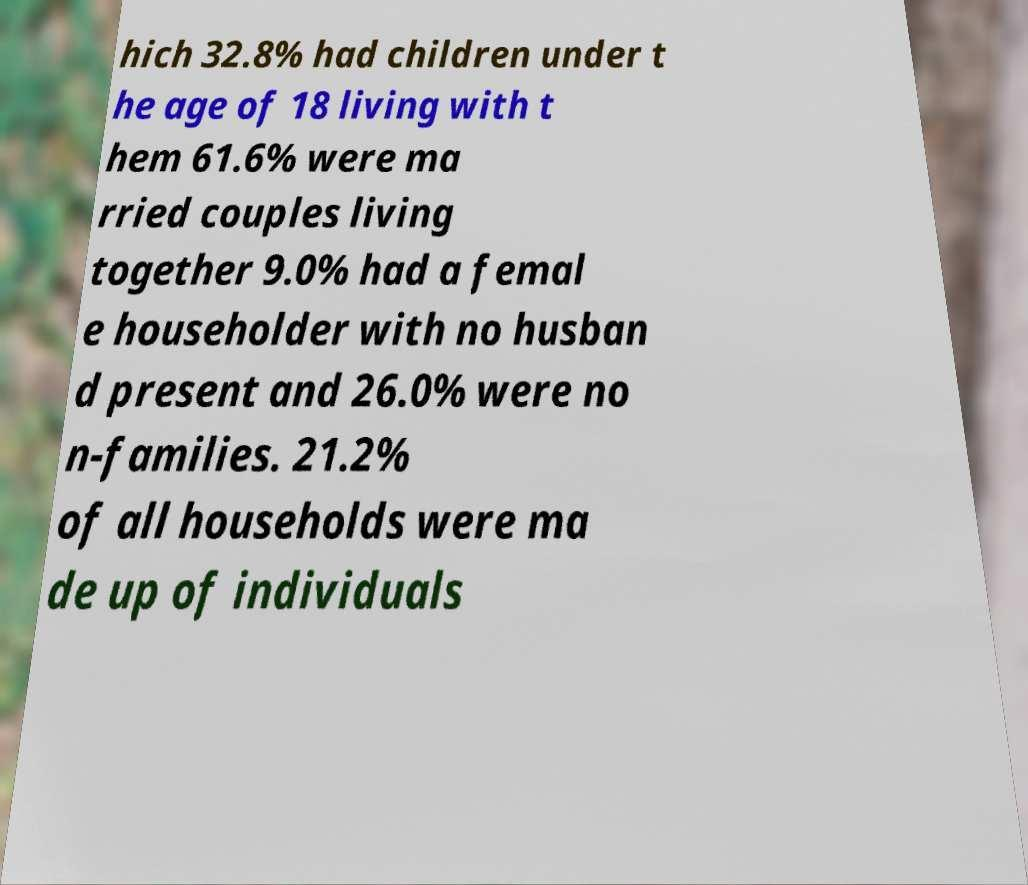Could you extract and type out the text from this image? hich 32.8% had children under t he age of 18 living with t hem 61.6% were ma rried couples living together 9.0% had a femal e householder with no husban d present and 26.0% were no n-families. 21.2% of all households were ma de up of individuals 